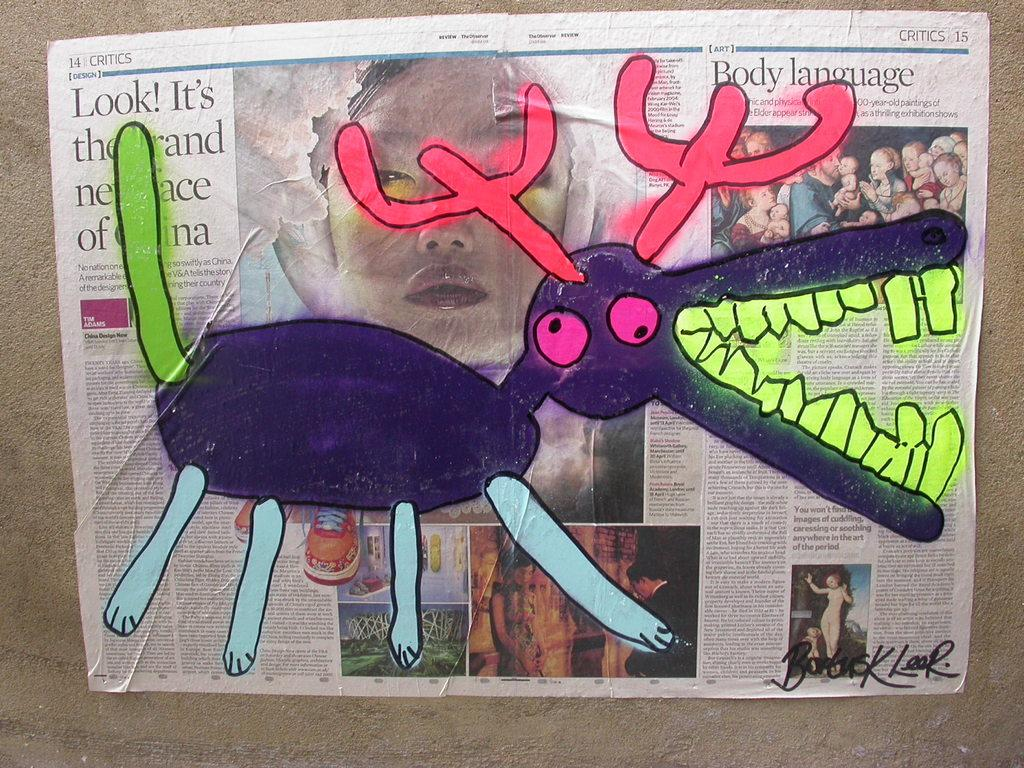What is on the wall in the image? There is a paper on the wall. What is depicted on the paper? The paper has a picture drawn on it. What type of body is visible in the image? There is no body present in the image; it features a paper with a picture drawn on it. What is the paper being used for in the image? The facts provided do not specify the purpose or use of the paper in the image. 